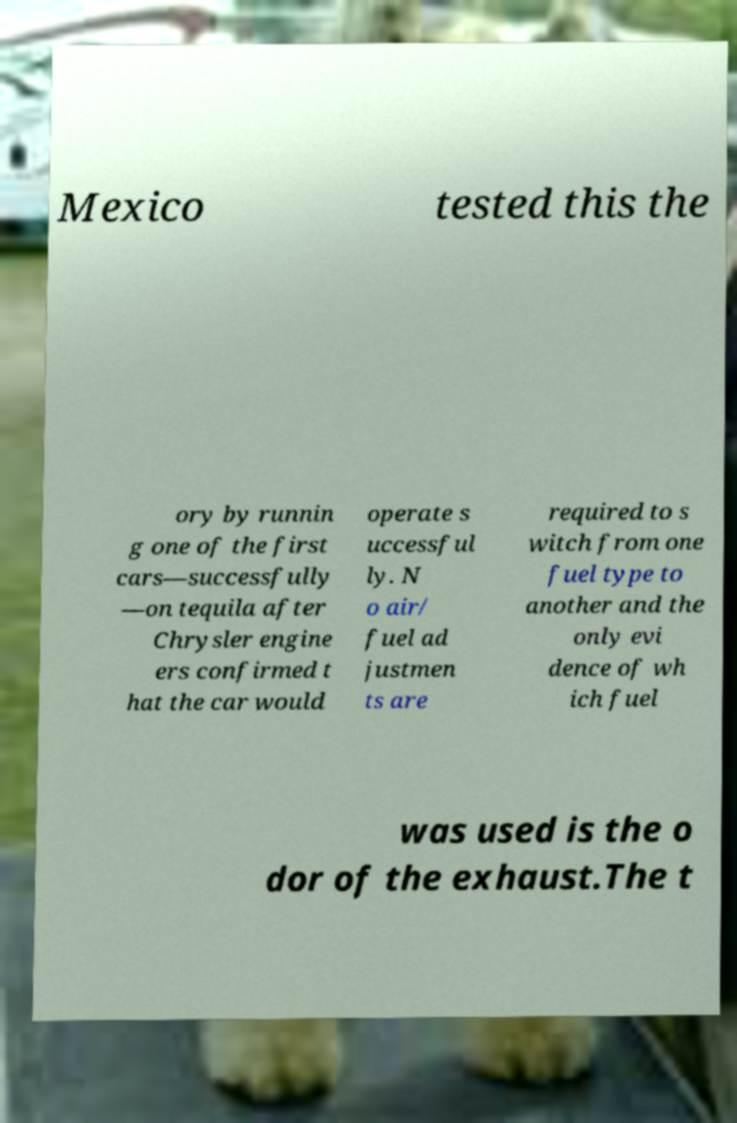There's text embedded in this image that I need extracted. Can you transcribe it verbatim? Mexico tested this the ory by runnin g one of the first cars—successfully —on tequila after Chrysler engine ers confirmed t hat the car would operate s uccessful ly. N o air/ fuel ad justmen ts are required to s witch from one fuel type to another and the only evi dence of wh ich fuel was used is the o dor of the exhaust.The t 